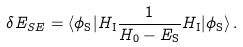<formula> <loc_0><loc_0><loc_500><loc_500>\delta E _ { S E } = \langle \phi _ { \mathrm S } | H _ { \mathrm I } \frac { 1 } { H _ { 0 } - E _ { \mathrm S } } H _ { \mathrm I } | \phi _ { \mathrm S } \rangle \, .</formula> 